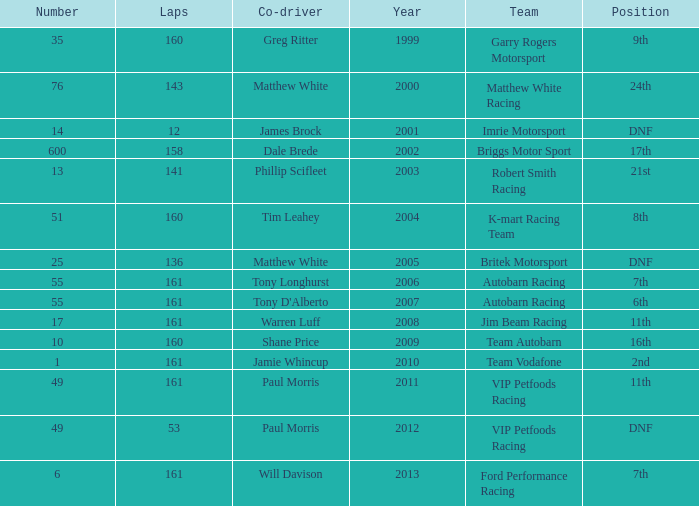What is the fewest laps for a team with a position of DNF and a number smaller than 25 before 2001? None. 